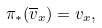Convert formula to latex. <formula><loc_0><loc_0><loc_500><loc_500>\pi _ { * } ( \overline { v } _ { x } ) = v _ { x } ,</formula> 